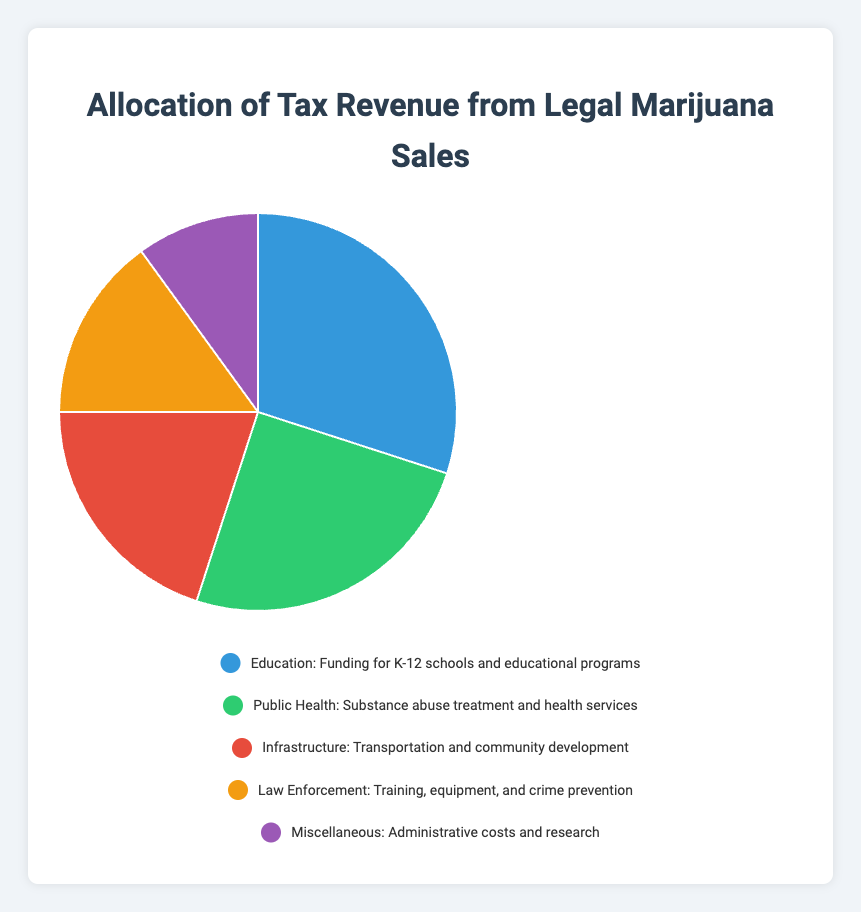What category receives the largest allocation of tax revenue? The pie chart visually depicts that the largest segment is labeled "Education" with a percentage of 30%. Hence, Education receives the largest allocation of tax revenue.
Answer: Education Which category receives more funding, Public Health or Infrastructure? The pie chart shows that Public Health receives 25% of tax revenue, while Infrastructure receives 20%. Therefore, Public Health receives more funding than Infrastructure.
Answer: Public Health What is the total percentage of the tax revenue allocated to Law Enforcement and Miscellaneous combined? From the chart, Law Enforcement receives 15% and Miscellaneous receives 10%. Adding these two values together gives 15% + 10% = 25%.
Answer: 25% By how much does the percentage allocated to Education exceed that of Law Enforcement? Education is allocated 30%, and Law Enforcement is allocated 15%. The difference between these two percentages is 30% - 15% = 15%.
Answer: 15% Which category has the smallest allocation of tax revenue? The pie chart indicates that the smallest segment is labeled "Miscellaneous," which has a percentage of 10%. Hence, Miscellaneous receives the smallest allocation of tax revenue.
Answer: Miscellaneous What is the difference in allocation percentage between Public Health and Law Enforcement? The percentage allocated to Public Health is 25%, whereas Law Enforcement is allocated 15%. The difference is 25% - 15% = 10%.
Answer: 10% If we combine the percentages of Public Health and Infrastructure, do they account for more than half of the total tax revenue? Public Health is allocated 25%, and Infrastructure is allocated 20%. Adding these gives 25% + 20% = 45%, which is less than half (50%) of the total tax revenue.
Answer: No How do the combined allocations for Public Health and Law Enforcement compare with the allocation for Education alone? Public Health is allocated 25% and Law Enforcement is 15%, combining to 25% + 15% = 40%. Education alone is allocated 30%. So, the combined funds for Public Health and Law Enforcement (40%) are greater than those for Education alone (30%).
Answer: Greater What is the average percentage allocation across all categories? To find the average, we sum all allocation percentages: 30% (Education) + 25% (Public Health) + 20% (Infrastructure) + 15% (Law Enforcement) + 10% (Miscellaneous) = 100%. Dividing by the number of categories (5), we get 100% / 5 = 20%.
Answer: 20% Is the allocation for Infrastructure more than one-third of the allocation for Education? The allocation for Infrastructure is 20%, and for Education, it is 30%. One-third of Education's allocation is 30% / 3 = 10%. Since 20% > 10%, the allocation for Infrastructure (20%) is indeed more than one-third of the allocation for Education (10%).
Answer: Yes 